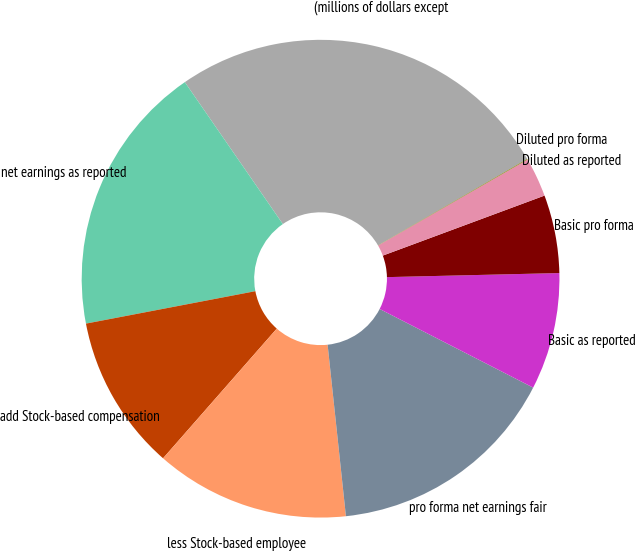Convert chart to OTSL. <chart><loc_0><loc_0><loc_500><loc_500><pie_chart><fcel>(millions of dollars except<fcel>net earnings as reported<fcel>add Stock-based compensation<fcel>less Stock-based employee<fcel>pro forma net earnings fair<fcel>Basic as reported<fcel>Basic pro forma<fcel>Diluted as reported<fcel>Diluted pro forma<nl><fcel>26.26%<fcel>18.39%<fcel>10.53%<fcel>13.15%<fcel>15.77%<fcel>7.91%<fcel>5.28%<fcel>2.66%<fcel>0.04%<nl></chart> 